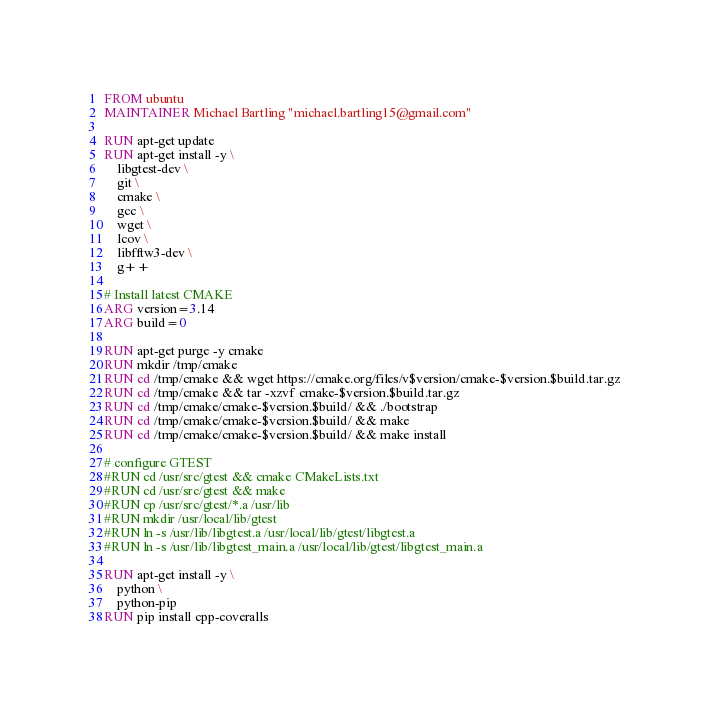<code> <loc_0><loc_0><loc_500><loc_500><_Dockerfile_>FROM ubuntu
MAINTAINER Michael Bartling "michael.bartling15@gmail.com"

RUN apt-get update
RUN apt-get install -y \
    libgtest-dev \
    git \
    cmake \
    gcc \
    wget \
    lcov \
    libfftw3-dev \
    g++ 

# Install latest CMAKE
ARG version=3.14
ARG build=0

RUN apt-get purge -y cmake
RUN mkdir /tmp/cmake
RUN cd /tmp/cmake && wget https://cmake.org/files/v$version/cmake-$version.$build.tar.gz
RUN cd /tmp/cmake && tar -xzvf cmake-$version.$build.tar.gz
RUN cd /tmp/cmake/cmake-$version.$build/ && ./bootstrap
RUN cd /tmp/cmake/cmake-$version.$build/ && make
RUN cd /tmp/cmake/cmake-$version.$build/ && make install

# configure GTEST
#RUN cd /usr/src/gtest && cmake CMakeLists.txt
#RUN cd /usr/src/gtest && make
#RUN cp /usr/src/gtest/*.a /usr/lib
#RUN mkdir /usr/local/lib/gtest
#RUN ln -s /usr/lib/libgtest.a /usr/local/lib/gtest/libgtest.a
#RUN ln -s /usr/lib/libgtest_main.a /usr/local/lib/gtest/libgtest_main.a

RUN apt-get install -y \
    python \
    python-pip
RUN pip install cpp-coveralls
</code> 